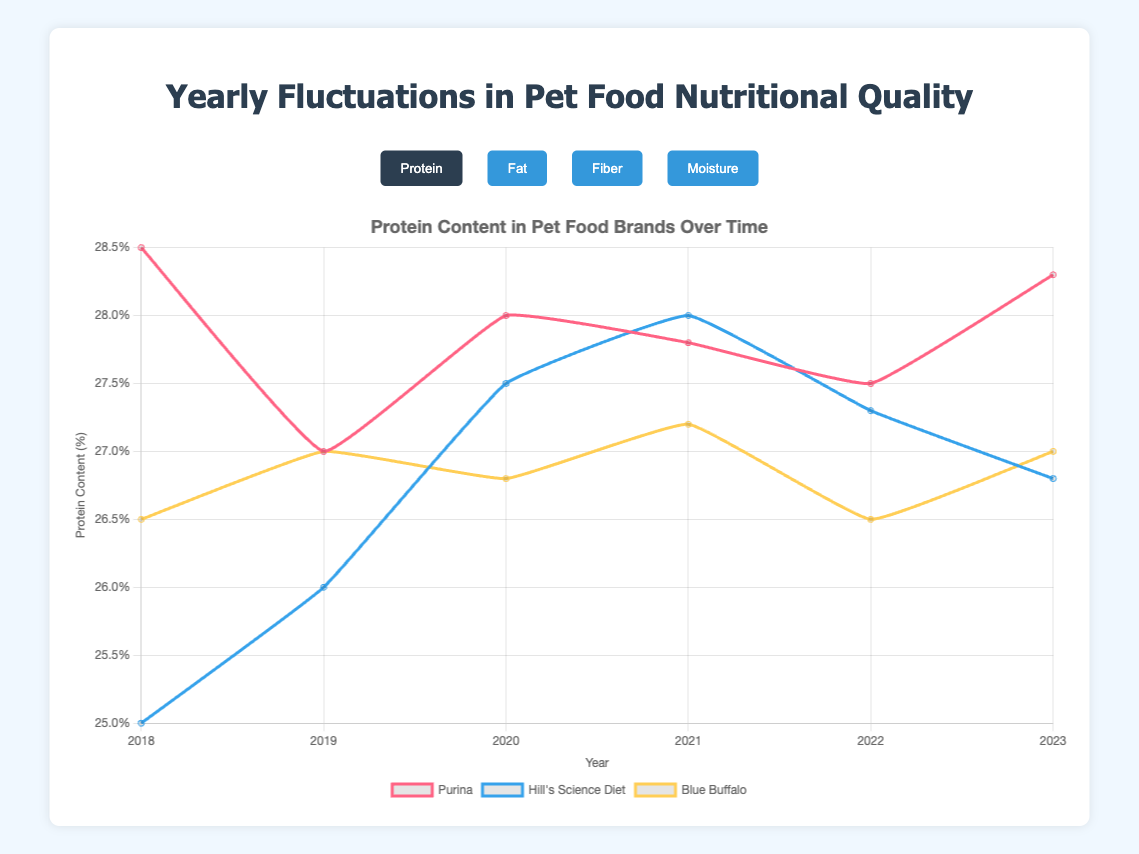Which pet food brand had the highest protein content in 2020? To determine the highest protein content in 2020, compare the "protein" data for all brands. For 2020, Purina had 28.0%, Hill's Science Diet had 27.5%, and Blue Buffalo had 26.8%. Purina has the highest protein content.
Answer: Purina How did the moisture content of Blue Buffalo change from 2018 to 2023? Compare the moisture content of Blue Buffalo in 2018 and in 2023. In 2018, it was 10.5%, and in 2023, it is 10.5%. Therefore, there was no change in moisture content for Blue Buffalo.
Answer: No change Which year had the highest average fat content among all brands, and what was that average? To find this, calculate the average fat content for each year, adding the fat percentages of all brands for that year and dividing by the number of brands. Then, identify the highest average. For each year:
2018: (18.2 + 16.0 + 17.0)/3 = 17.07%
2019: (18.5 + 15.5 + 16.8)/3 = 16.93%
2020: (17.8 + 15.2 + 17.2)/3 = 16.73%
2021: (18.0 + 15.0 + 16.5)/3 = 16.5%
2022: (18.3 + 15.6 + 17.1)/3 = 17.0%
2023: (18.8 + 15.3 + 16.9)/3 = 17.0%
The highest average fat content year was 2018 with 17.07%.
Answer: 2018, 17.07% Which brand showed the most variation in fiber content from 2018 to 2023? To find this, calculate the range (difference between maximum and minimum values) of fiber content for each brand. For each brand:
Purina: max(3.0, 2.8, 2.5, 3.0, 2.6, 2.7) - min(3.0, 2.8, 2.5, 3.0, 2.6, 2.7) = 3.0 - 2.5 = 0.5
Hill's Science Diet: max(3.4, 3.0, 3.2, 3.1, 3.3, 3.0) - min(3.4, 3.0, 3.2, 3.1, 3.3, 3.0) = 3.4 - 3.0 = 0.4
Blue Buffalo: max(4.3, 4.0, 3.8, 4.1, 4.2, 4.0) - min(4.3, 4.0, 3.8, 4.1, 4.2, 4.0) = 4.3 - 3.8 = 0.5
Purina and Blue Buffalo both have the most variation in fiber content.
Answer: Purina and Blue Buffalo In which year did Hill's Science Diet have the lowest fat content, and what was it? Compare the fat percentages for Hill's Science Diet each year to identify the lowest value:
2018: 16.0%
2019: 15.5%
2020: 15.2%
2021: 15.0%
2022: 15.6%
2023: 15.3%
The lowest fat content for Hill's Science Diet was in 2021 with 15.0%.
Answer: 2021, 15.0% Compare the protein content trends of Purina and Hill's Science Diet from 2018 to 2023. Observe the trend lines for protein content for both brands from 2018 to 2023. Purina has fluctuated but largely ranged between 27.0% and 28.5%, trending back up to 28.3% in 2023. Hill's Science Diet started at 25.0% in 2018, increased over the years to a peak of 28.0% in 2021, and then decreased to 26.8% in 2023.
Answer: Purina fluctuated; Hill's Science Diet rose then fell Which brand had the closest moisture content values across all years, indicating low variability? Calculate the range of moisture content for each brand from 2018 to 2023. The lower the range, the closer the values.
Purina: max(10.5%, 10.0%, 10.2%, 10.1%, 10.4%, 10.2%) - min(10.5%, 10.0%, 10.2%, 10.1%, 10.4%, 10.2%) = 10.5% - 10.0% = 0.5%
Hill's Science Diet: max(11.0%, 10.8%, 10.9%, 10.5%, 10.7%, 10.8%) - min(11.0%, 10.8%, 10.9%, 10.5%, 10.7%, 10.8%) = 11.0% - 10.5% = 0.5%
Blue Buffalo: max(10.6%, 10.5%, 10.3%, 10.6%, 10.4%, 10.5%) - min(10.6%, 10.5%, 10.3%, 10.6%, 10.4%, 10.5%) = 10.6% - 10.3% = 0.3%
Blue Buffalo had the closest moisture content values.
Answer: Blue Buffalo 